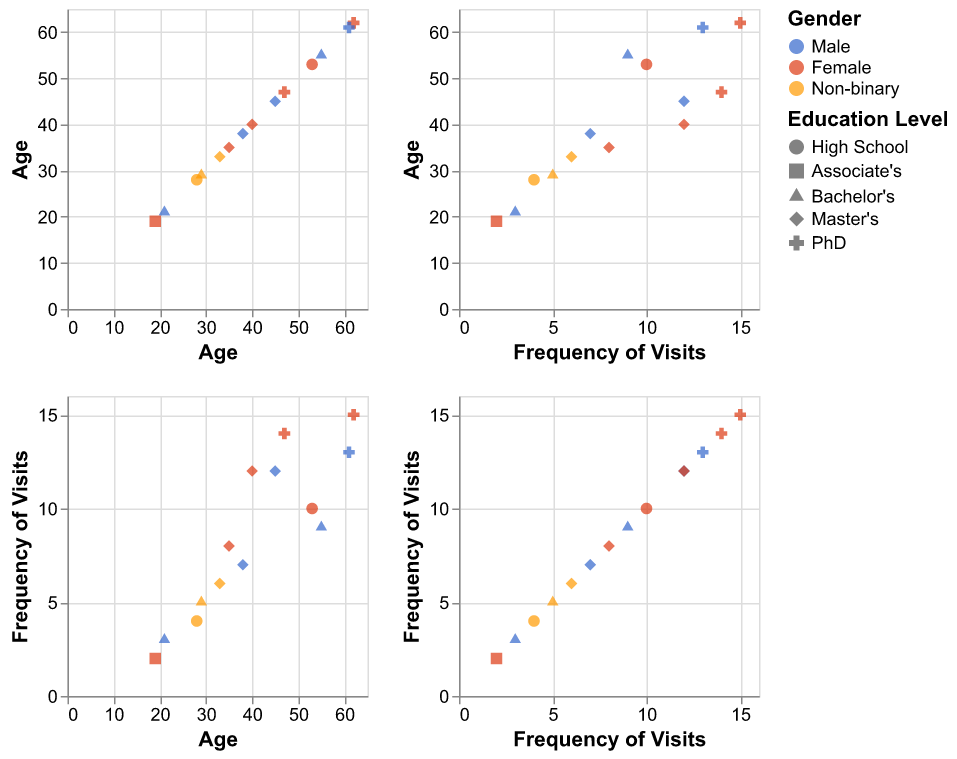What are the different shapes used for Education Level? The plot legend shows that the shapes representing different education levels are circles, squares, triangles, diamonds, and crosses.
Answer: Circles, Squares, Triangles, Diamonds, Crosses Which gender has the most representation in the dataset? By counting the data points for each color representing gender, we see that Female (red) has the most representation.
Answer: Female What is the age range of visitors with a Master's degree? Observing the x-axis for data points with diamond shapes, we see ranges approximately from ages 33 to 45.
Answer: 33 to 45 How frequent are visits for those who identify as Non-binary? For data points colored in orange, the frequencies (y-values) are: 5, 6, 4, which range between 4 and 6 visits.
Answer: 4 to 6 visits Is there a notable relationship between age and frequency of visits? Looking at the scatter plot between Age and Frequency of Visits, we can see a general upward trend, indicating that older visitors tend to visit more frequently.
Answer: Yes, older visitors tend to visit more frequently What is the average age of visitors who visit at least 10 times a year? First, identify the points where Frequency of Visits >= 10 (12, 15, 14, 13, 10, 12), then calculate the average age of these points ((45 + 62 + 47 + 61 + 53 + 40) / 6)
Answer: 51.3 What age group has the lowest frequency of visits? From the Age vs. Frequency of Visits plot, the youngest visitors (ages 19-21) are seen with the lowest visit frequencies (2-3 visits).
Answer: Age 19-21 Which education level has the highest frequency of visits per individual? By observing the plot, those with PhDs (cross shapes) show the highest average visit frequencies (15, 14, 13).
Answer: PhD How does the frequency of visits vary among different genders? By comparing the colors of data points across the Frequency of Visits axis, we note that Females (red) have more consistent higher visit frequencies, while Males (blue) and Non-binary (orange) have fewer and less frequent visits.
Answer: Females visit more frequently What is the age range and education level of visitors who visit the most often (15 visits)? Identify the point where Frequency of Visits = 15, correlate the data point's shape to education level, and read the value on the Age axis; the visitor is age 62 with a PhD (cross shape).
Answer: Age 62, PhD 